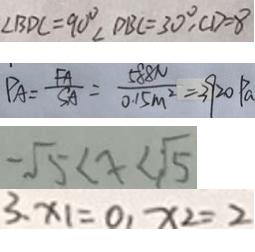<formula> <loc_0><loc_0><loc_500><loc_500>\angle B D C = 9 0 ^ { \circ } \angle D B C = 3 0 ^ { \circ } , C D = 8 
 P A = \frac { F A } { S A } = \frac { 5 8 8 N } { 0 . 1 5 m ^ { 2 } } = 3 9 2 0 P a 
 - \sqrt { 5 } < x < \sqrt { 5 } 
 3 、 x _ { 1 } = 0 , x _ { 2 } = 2</formula> 